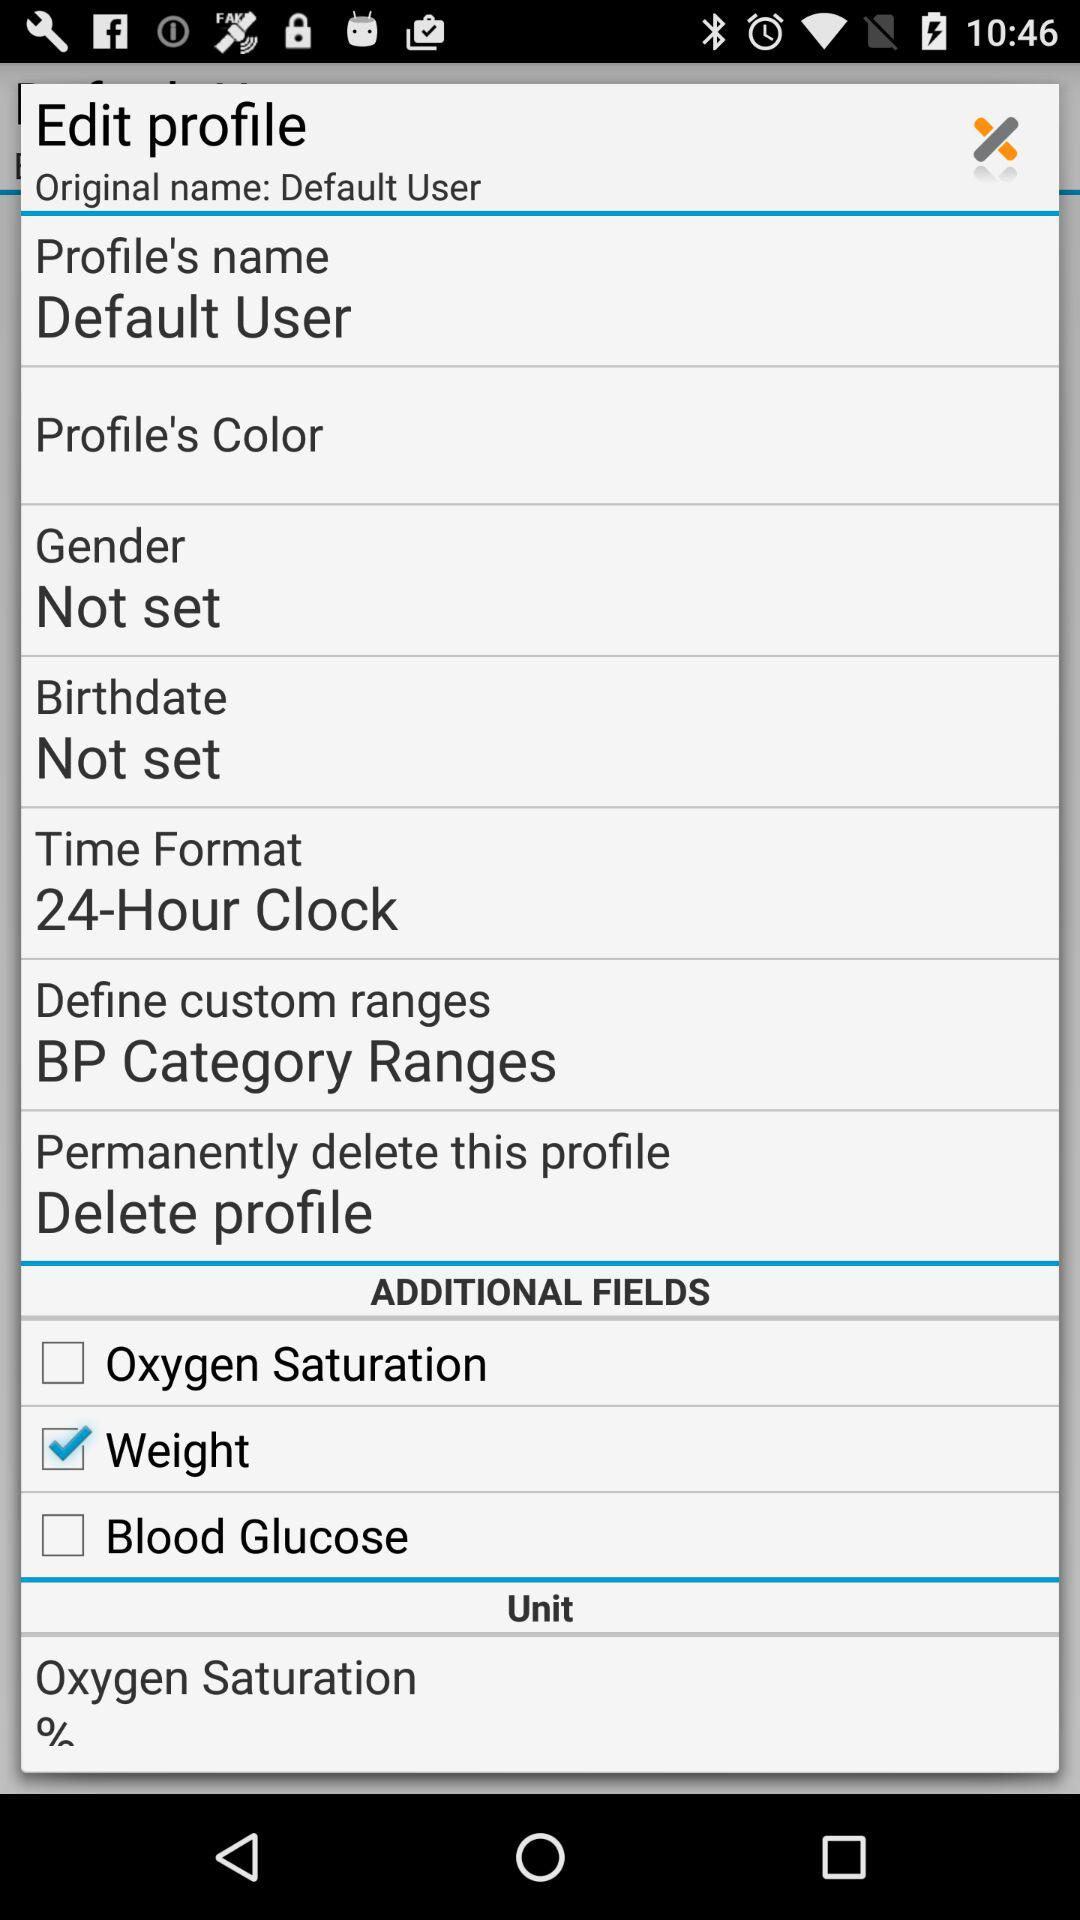What is the status of the birthdate? The status is "Not set". 